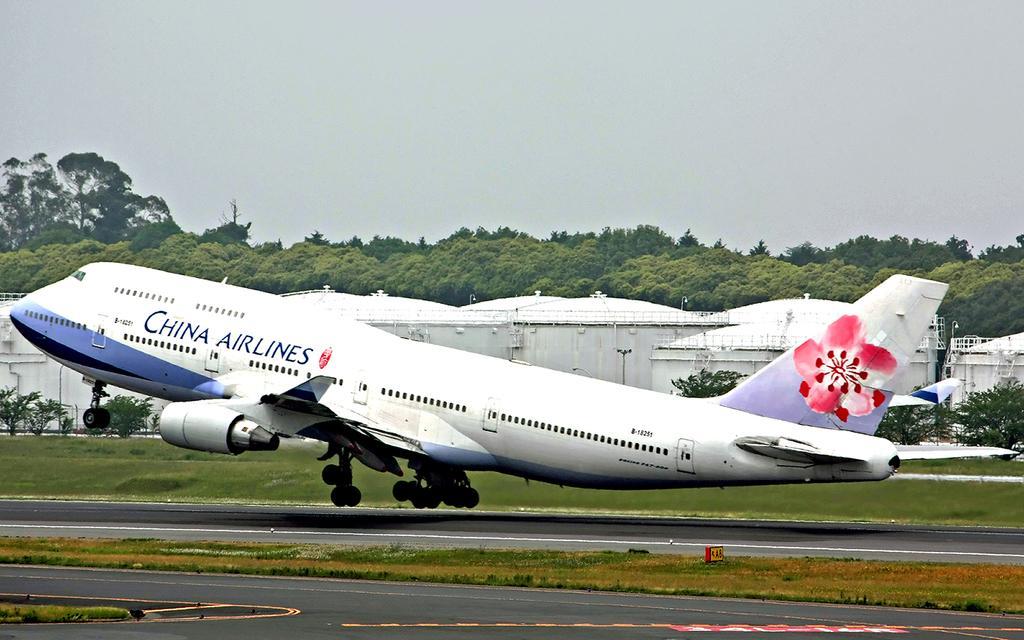Can you describe this image briefly? Here in this picture we can see an airplane present on the runway over there and we can see some part of ground is covered with grass over there and behind that we can see sheds present all over there and we can see trees and plants present all over there. 